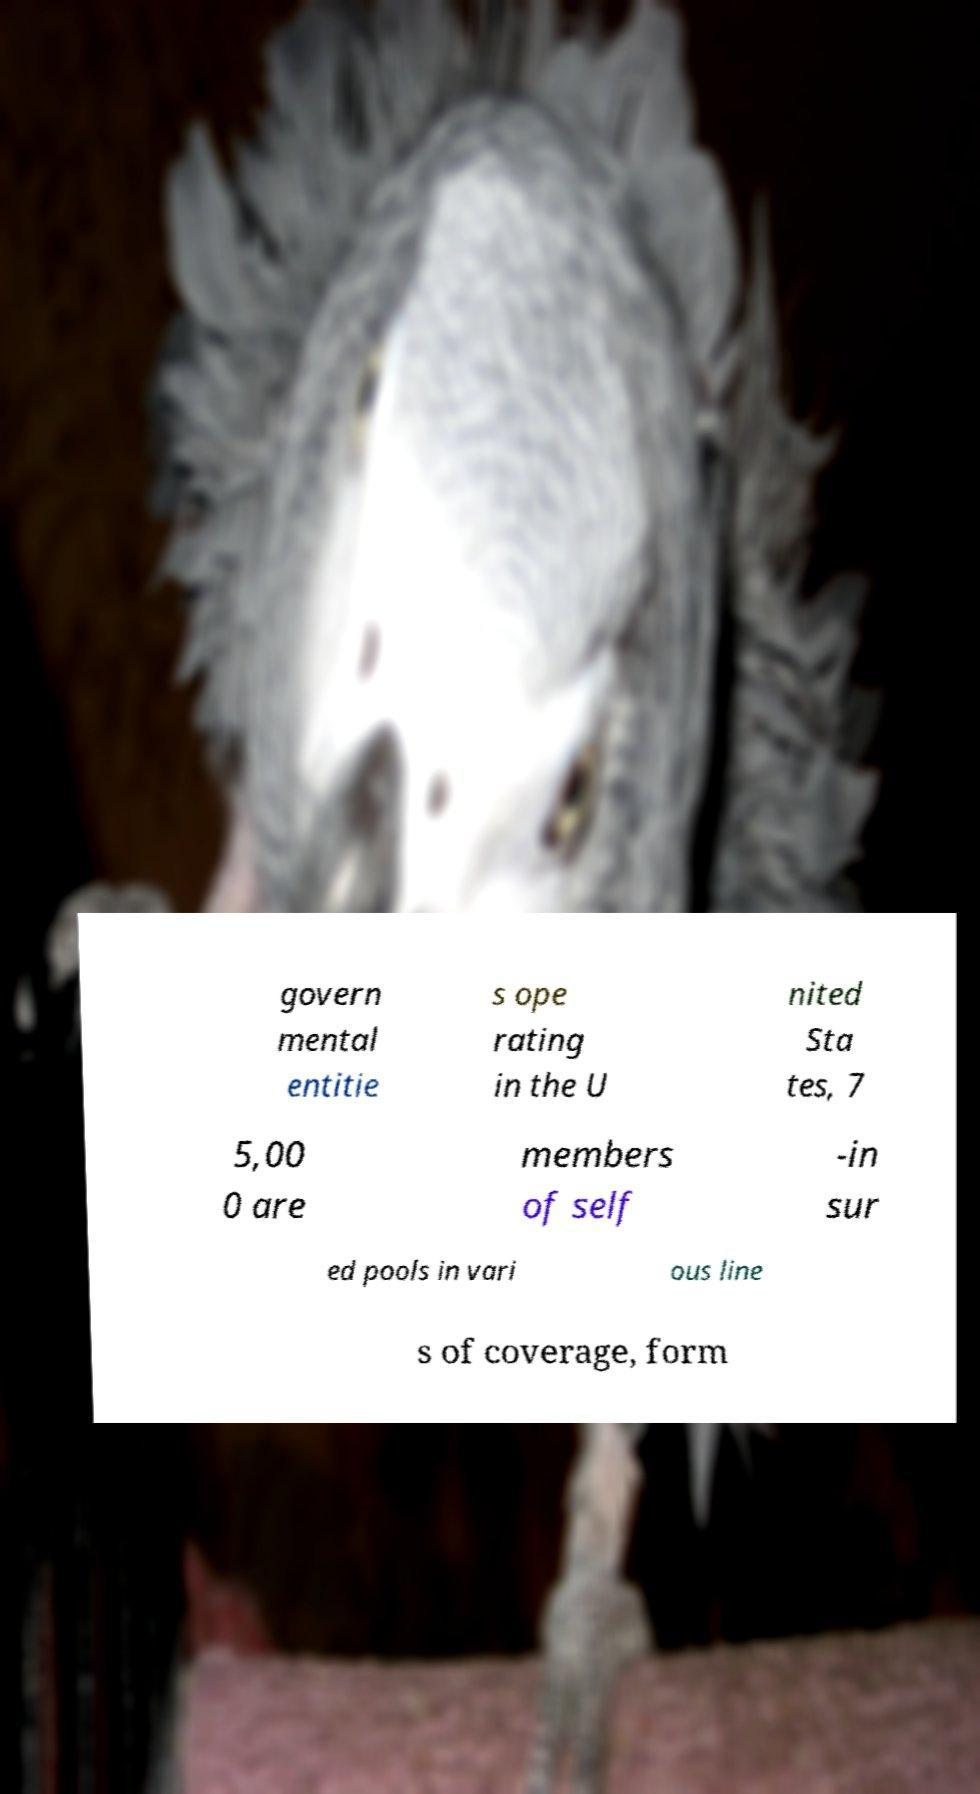Can you read and provide the text displayed in the image?This photo seems to have some interesting text. Can you extract and type it out for me? govern mental entitie s ope rating in the U nited Sta tes, 7 5,00 0 are members of self -in sur ed pools in vari ous line s of coverage, form 